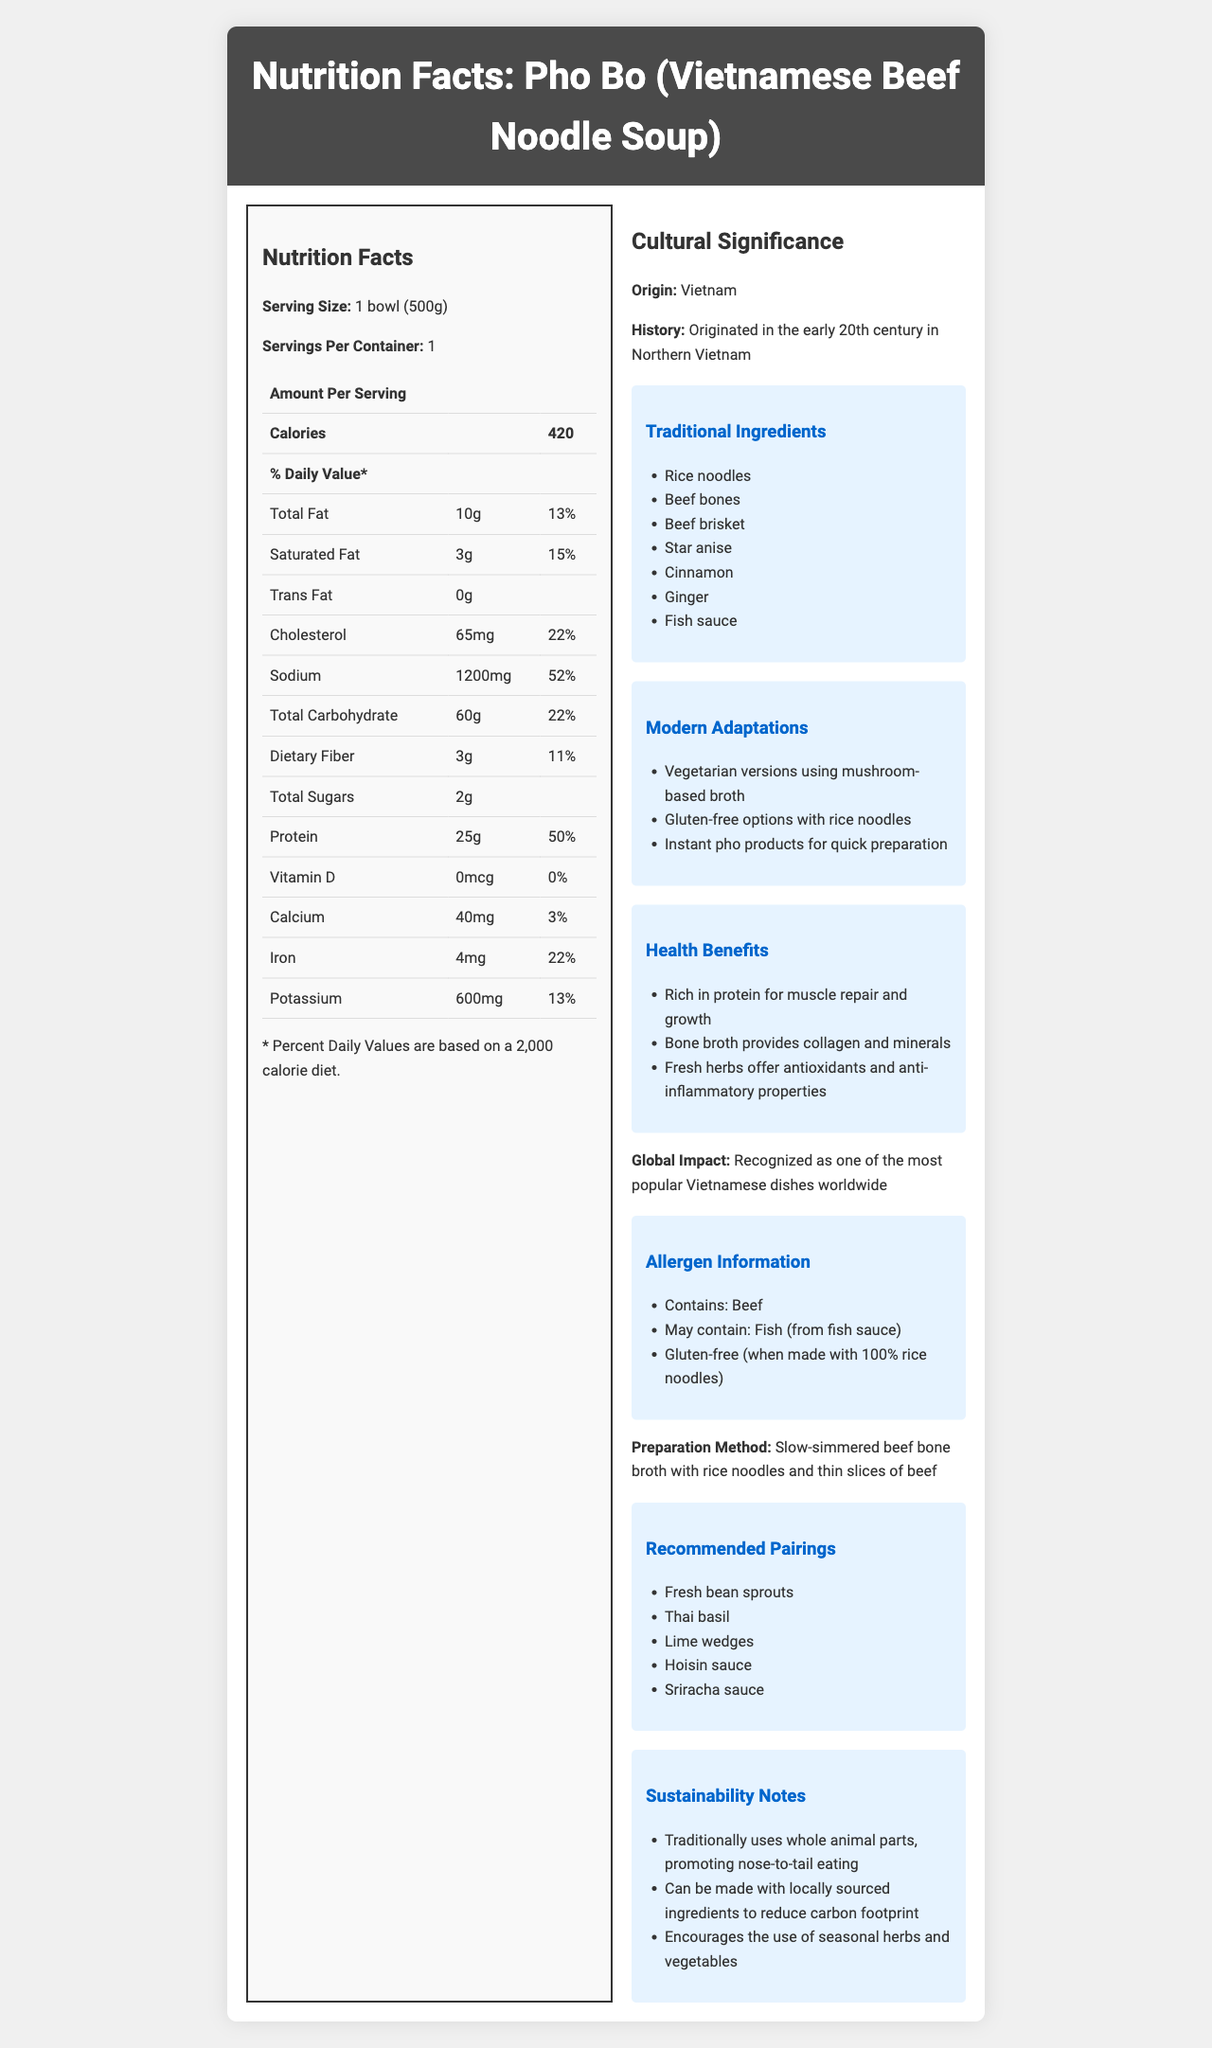what is the serving size for Pho Bo? The serving size is clearly stated under the nutrition facts section.
Answer: 1 bowl (500g) how many calories does one serving of Pho Bo contain? The calories per serving are listed in the nutrition facts table.
Answer: 420 what percentage of the daily value of sodium is in one serving of Pho Bo? The sodium content and its corresponding daily value percentage are both listed in the nutrition facts table.
Answer: 52% what are some traditional ingredients used in Pho Bo? These ingredients are mentioned in the traditional ingredients section of the cultural overview.
Answer: Rice noodles, Beef bones, Beef brisket, Star anise, Cinnamon, Ginger, Fish sauce what are some health benefits of consuming Pho Bo? These benefits are highlighted in the health benefits section.
Answer: Rich in protein, Bone broth provides collagen and minerals, Fresh herbs offer antioxidants and anti-inflammatory properties which of the following ingredients is not listed as a traditional ingredient in Pho Bo? A. Ginger B. Chicken Bones C. Star Anise D. Beef Brisket Chicken bones are not mentioned among the traditional ingredients; beef bones are listed instead.
Answer: B. Chicken Bones what allergen information is provided for Pho Bo? A. Contains: Chicken, May contain: Fish B. Contains: Beef, May contain: Fish C. Contains: Beef, May contain: Soy D. Contains: Fish, May contain: Chicken The allergen information section specifies that Pho Bo contains beef and may contain fish from fish sauce.
Answer: B. Contains: Beef, May contain: Fish is Pho Bo gluten-free when made with 100% rice noodles? The allergen information confirms it is gluten-free when made with 100% rice noodles.
Answer: Yes summarize the main idea of the document. The summary captures the essence of the document, combining both the nutritional details and cultural significance of Pho Bo.
Answer: The document provides detailed nutritional information and cultural context for Pho Bo (Vietnamese Beef Noodle Soup), including its origins, traditional and modern adaptations, health benefits, allergen information, preparation methods, recommended pairings, and sustainability notes. does the document provide any information on the environmental benefits of Pho Bo? The sustainability notes mention several environmental benefits such as promoting nose-to-tail eating, using locally-sourced ingredients, and encouraging the use of seasonal herbs and vegetables.
Answer: Yes what is the total carbohydrate content in one serving of Pho Bo? The total carbohydrate amount is listed in the nutrition facts section.
Answer: 60g how has Pho Bo been adapted in modern culinary practices? These modern adaptations are detailed in the cultural significance section.
Answer: Vegetarian versions using mushroom-based broth, Gluten-free options with rice noodles, Instant pho products for quick preparation how is Pho Bo traditionally prepared? The preparation method section describes the traditional preparation process.
Answer: Slow-simmered beef bone broth with rice noodles and thin slices of beef what percentage of the daily value of iron is in one serving of Pho Bo? The percentage is provided in the nutrition facts under iron.
Answer: 22% what is the potassium content in one serving of Pho Bo? The potassium content is detailed in the nutrition facts section.
Answer: 600mg did Pho Bo originate in the southern part of Vietnam? The document specifies that Pho Bo originated in the early 20th century in Northern Vietnam.
Answer: No is the vitamin D content in Pho Bo significant? The nutrition facts reveal that the vitamin D content is 0 mcg with a 0% daily value.
Answer: No what type of dish is Pho Bo globally recognized as? The global impact section explains its international recognition.
Answer: One of the most popular Vietnamese dishes worldwide does the document state the specific recipes of instant pho products? The document mentions the existence of instant pho products for quick preparation but does not provide specific recipes.
Answer: Not enough information 